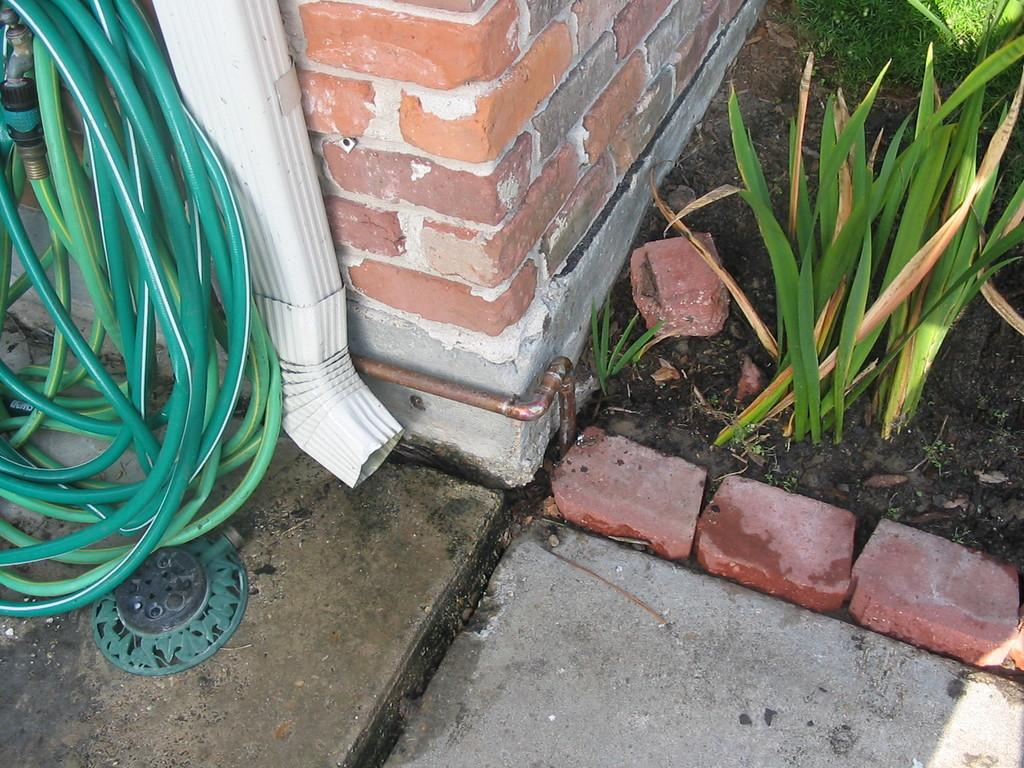What object is located on the left side of the image? There is a water pipe on the left side of the image. What is the color of the water pipe? The water pipe is green in color. What can be seen on the right side of the image? There are plants on the right side of the image. What type of structure is in the middle of the image? There is a brick wall in the middle of the image. How does the water pipe push the snow away in the image? There is no snow present in the image, and the water pipe is not pushing anything away. 